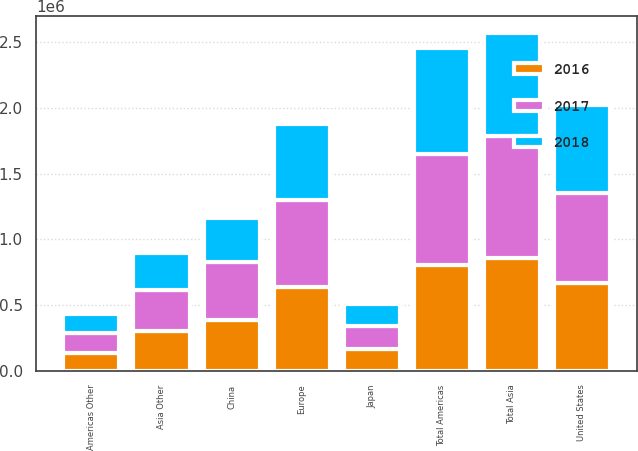Convert chart to OTSL. <chart><loc_0><loc_0><loc_500><loc_500><stacked_bar_chart><ecel><fcel>China<fcel>Japan<fcel>Asia Other<fcel>Total Asia<fcel>United States<fcel>Americas Other<fcel>Total Americas<fcel>Europe<nl><fcel>2017<fcel>443321<fcel>173357<fcel>305613<fcel>922291<fcel>683596<fcel>151581<fcel>835177<fcel>662461<nl><fcel>2016<fcel>387059<fcel>167258<fcel>308300<fcel>862617<fcel>669274<fcel>140715<fcel>809989<fcel>636472<nl><fcel>2018<fcel>331354<fcel>167977<fcel>283653<fcel>782984<fcel>665280<fcel>141902<fcel>807182<fcel>577257<nl></chart> 